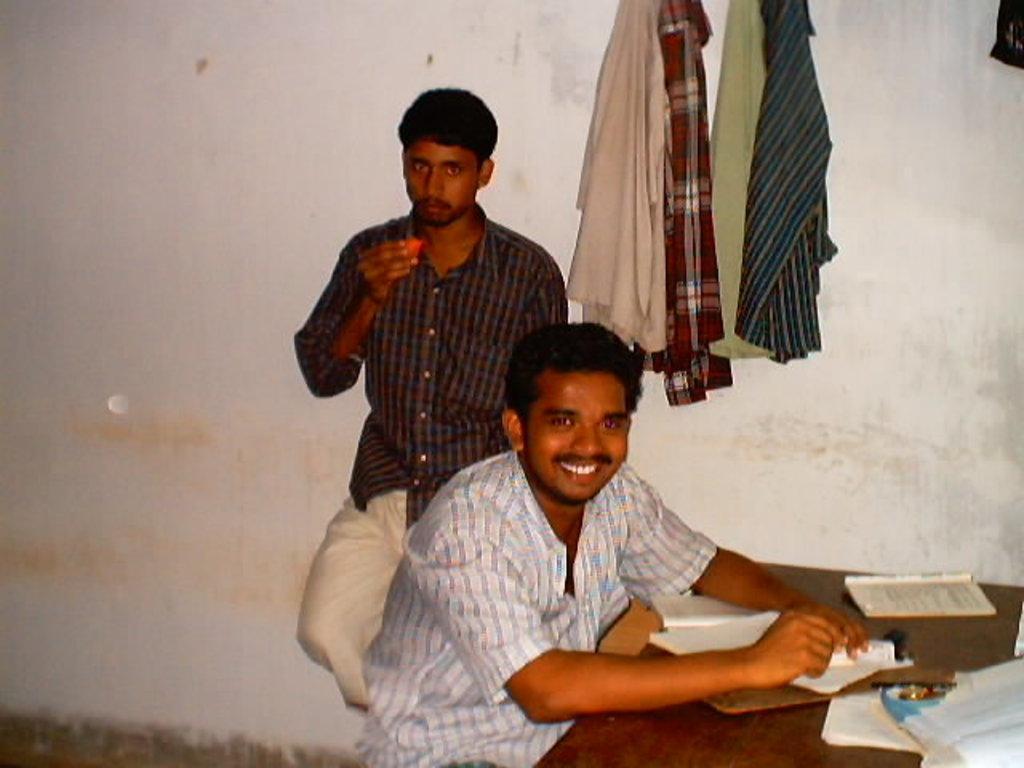In one or two sentences, can you explain what this image depicts? In the image we can see there are two men. A man who is sitting and another man is standing and in front of the man there is table on which there are books and on the wall there are shirts hanging. 